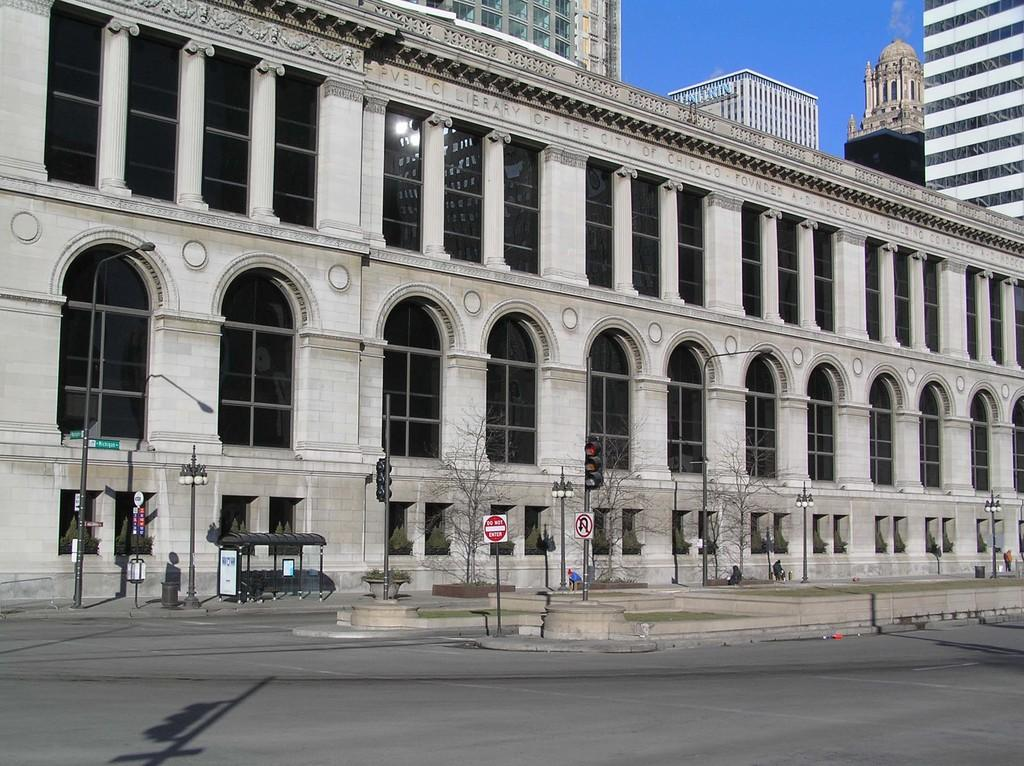What is the main feature of the image? There is a road in the image. What other structures can be seen along the road? There are poles, sign boards, traffic signals, and lights in the image. What type of vegetation is present in the image? There are trees in the image. What type of buildings can be seen in the image? There are buildings with windows in the image. What else is visible in the image? There are some objects and the sky in the background of the image. What type of battle is taking place in the image? There is no battle present in the image; it features a road, structures, and other elements. What type of ray can be seen emanating from the traffic signals? There are no rays emanating from the traffic signals in the image; they are simply displaying their colors to regulate traffic. 